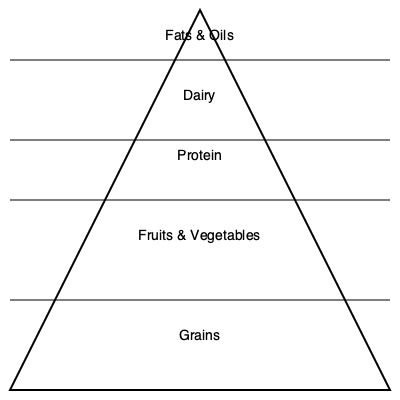As a youth sports coach, you're planning a team nutrition workshop. Based on the food pyramid shown, which food group should form the foundation of your athletes' diets, and approximately what percentage of their daily intake should it represent? To answer this question, we need to analyze the food pyramid graphic and understand its structure:

1. The pyramid is divided into five sections, with the largest section at the bottom and the smallest at the top.

2. The sections, from bottom to top, represent:
   - Grains
   - Fruits & Vegetables
   - Protein
   - Dairy
   - Fats & Oils

3. In a food pyramid, the largest section at the base represents the food group that should form the foundation of a healthy diet and be consumed in the largest quantities.

4. In this case, the largest section at the base of the pyramid is labeled "Grains."

5. To estimate the percentage, we can roughly divide the pyramid into quarters:
   - Grains occupy about 1/3 of the total area
   - Fruits & Vegetables occupy about 1/4
   - Protein occupies about 1/6
   - Dairy occupies about 1/8
   - Fats & Oils occupy about 1/12

6. Converting 1/3 to a percentage: $\frac{1}{3} \approx 33.33\%$

7. Rounding to the nearest 5%, we get 35%

Therefore, grains should form the foundation of the athletes' diets, representing approximately 35% of their daily intake.
Answer: Grains, approximately 35% of daily intake 